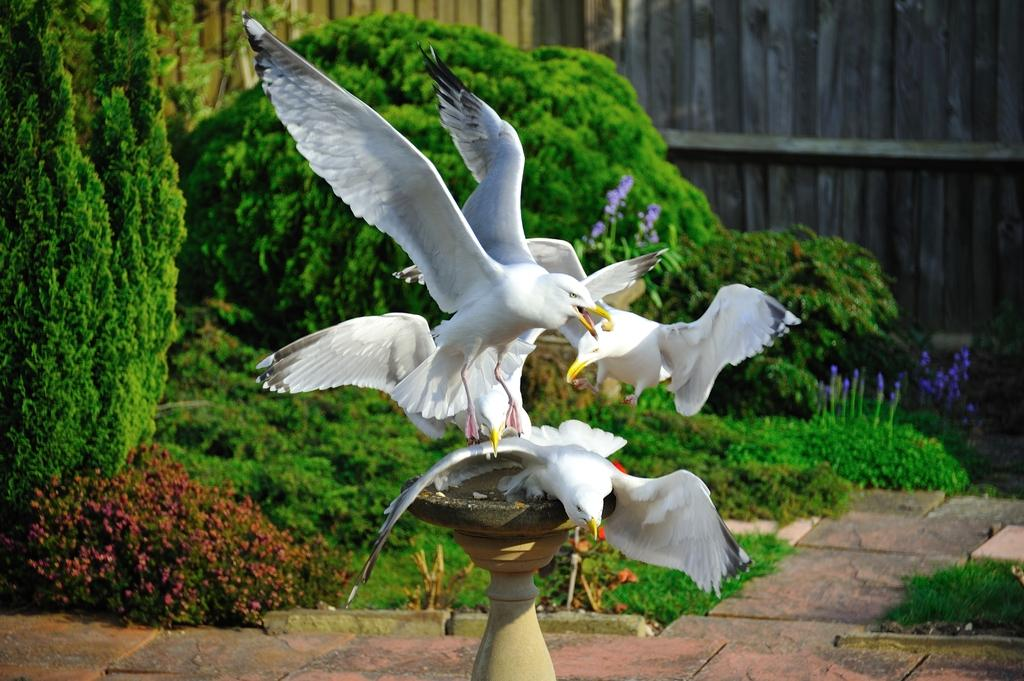What is located in the center of the image? There are birds in the center of the image. What is at the bottom of the image? There is a pedestal at the bottom of the image. What can be seen in the background of the image? There are bushes and a fence in the background of the image. What type of secretary can be seen working in the garden in the image? There is no secretary or garden present in the image; it features birds, a pedestal, bushes, and a fence. 